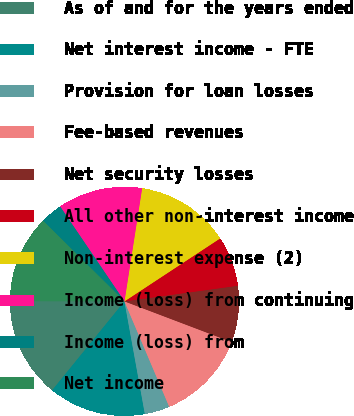Convert chart to OTSL. <chart><loc_0><loc_0><loc_500><loc_500><pie_chart><fcel>As of and for the years ended<fcel>Net interest income - FTE<fcel>Provision for loan losses<fcel>Fee-based revenues<fcel>Net security losses<fcel>All other non-interest income<fcel>Non-interest expense (2)<fcel>Income (loss) from continuing<fcel>Income (loss) from<fcel>Net income<nl><fcel>14.16%<fcel>13.72%<fcel>3.54%<fcel>12.83%<fcel>7.96%<fcel>7.08%<fcel>13.27%<fcel>11.95%<fcel>3.1%<fcel>12.39%<nl></chart> 